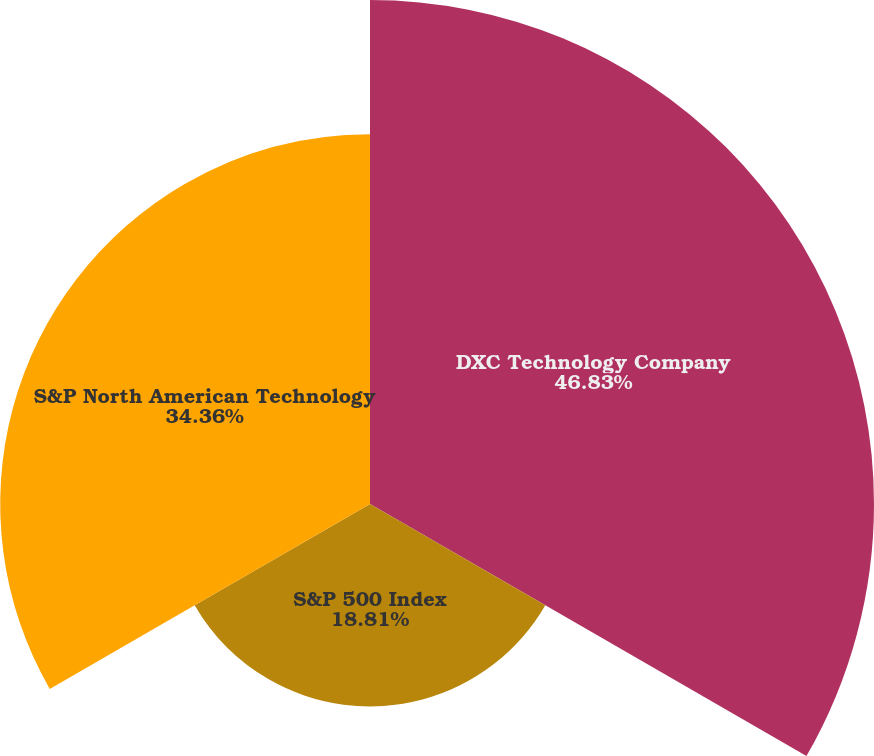Convert chart. <chart><loc_0><loc_0><loc_500><loc_500><pie_chart><fcel>DXC Technology Company<fcel>S&P 500 Index<fcel>S&P North American Technology<nl><fcel>46.83%<fcel>18.81%<fcel>34.36%<nl></chart> 